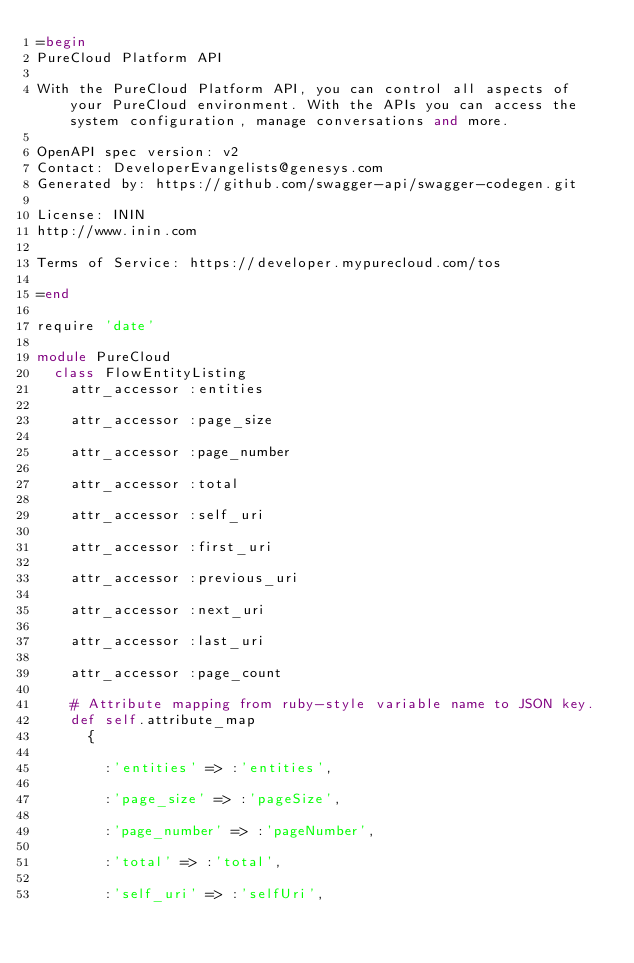<code> <loc_0><loc_0><loc_500><loc_500><_Ruby_>=begin
PureCloud Platform API

With the PureCloud Platform API, you can control all aspects of your PureCloud environment. With the APIs you can access the system configuration, manage conversations and more.

OpenAPI spec version: v2
Contact: DeveloperEvangelists@genesys.com
Generated by: https://github.com/swagger-api/swagger-codegen.git

License: ININ
http://www.inin.com

Terms of Service: https://developer.mypurecloud.com/tos

=end

require 'date'

module PureCloud
  class FlowEntityListing
    attr_accessor :entities

    attr_accessor :page_size

    attr_accessor :page_number

    attr_accessor :total

    attr_accessor :self_uri

    attr_accessor :first_uri

    attr_accessor :previous_uri

    attr_accessor :next_uri

    attr_accessor :last_uri

    attr_accessor :page_count

    # Attribute mapping from ruby-style variable name to JSON key.
    def self.attribute_map
      {
        
        :'entities' => :'entities',
        
        :'page_size' => :'pageSize',
        
        :'page_number' => :'pageNumber',
        
        :'total' => :'total',
        
        :'self_uri' => :'selfUri',
        </code> 